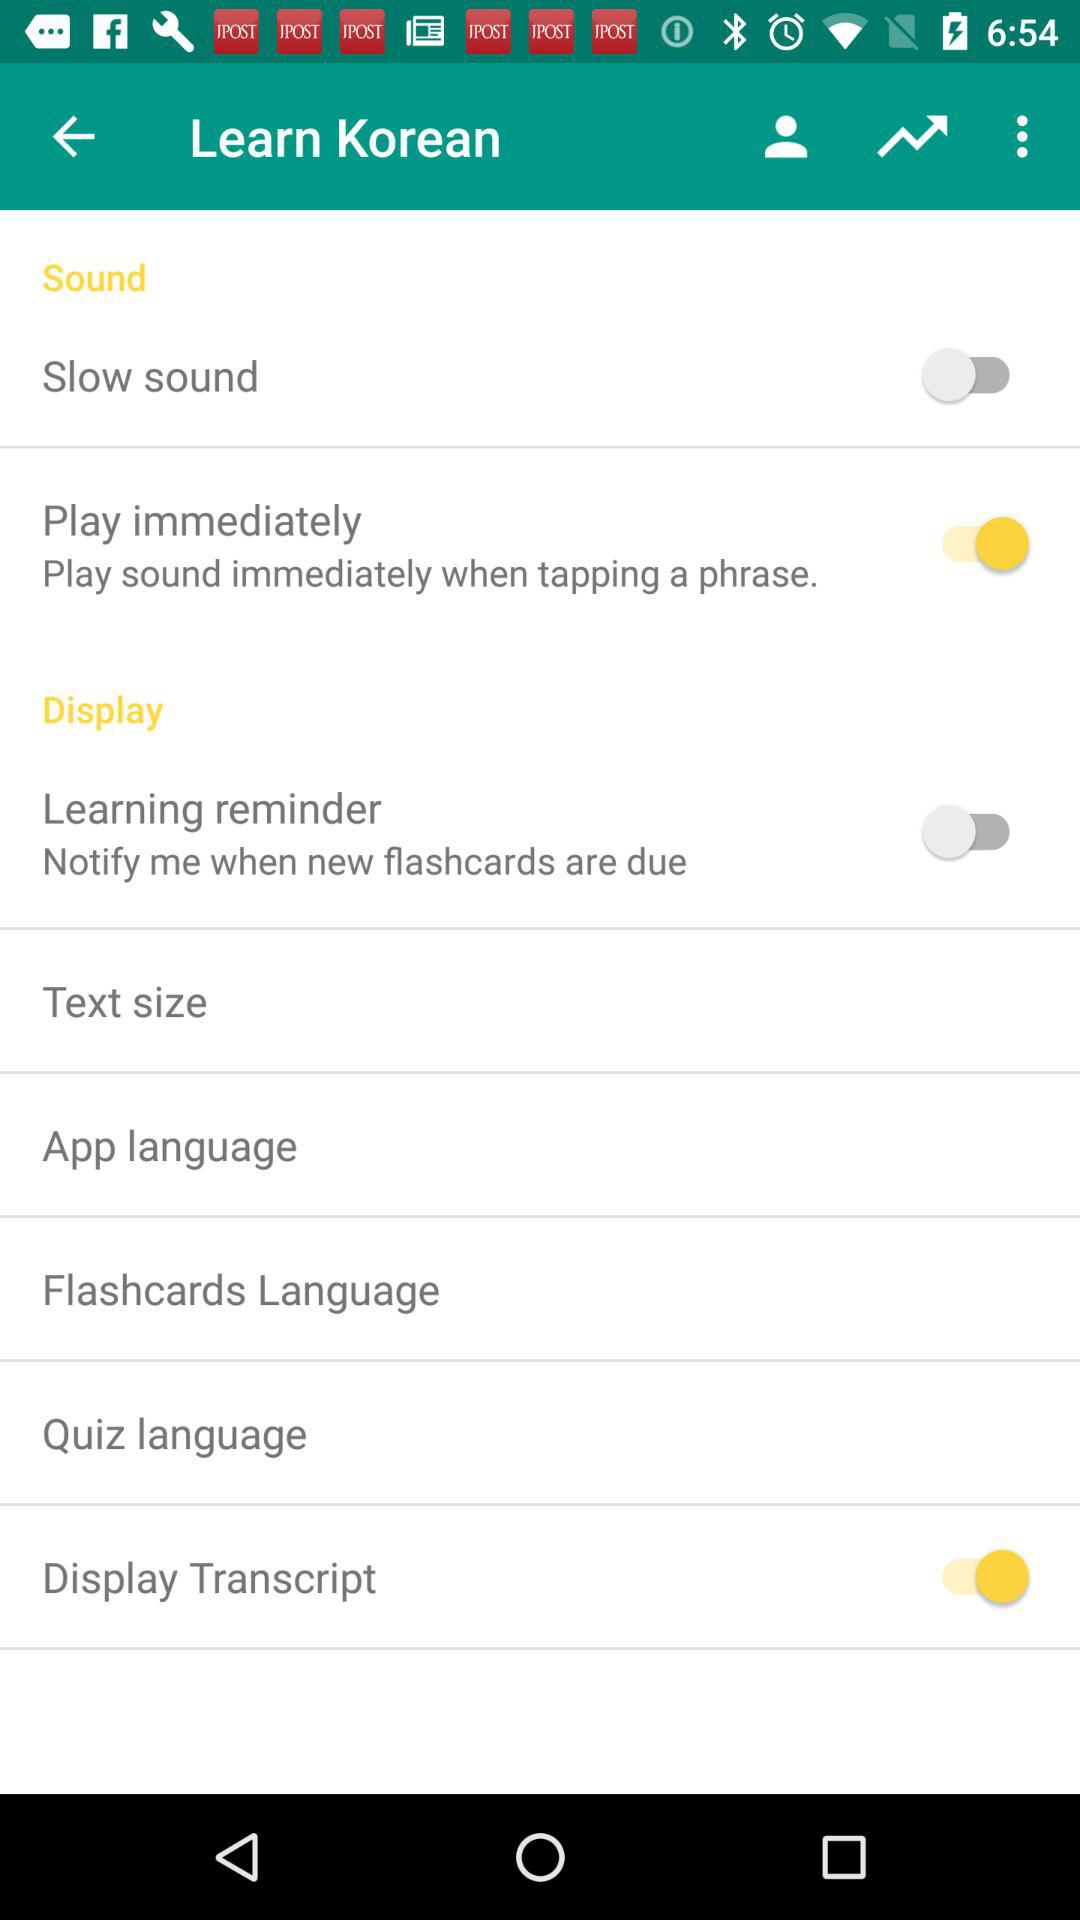What is the status of "Play immediately"? The status is "on". 